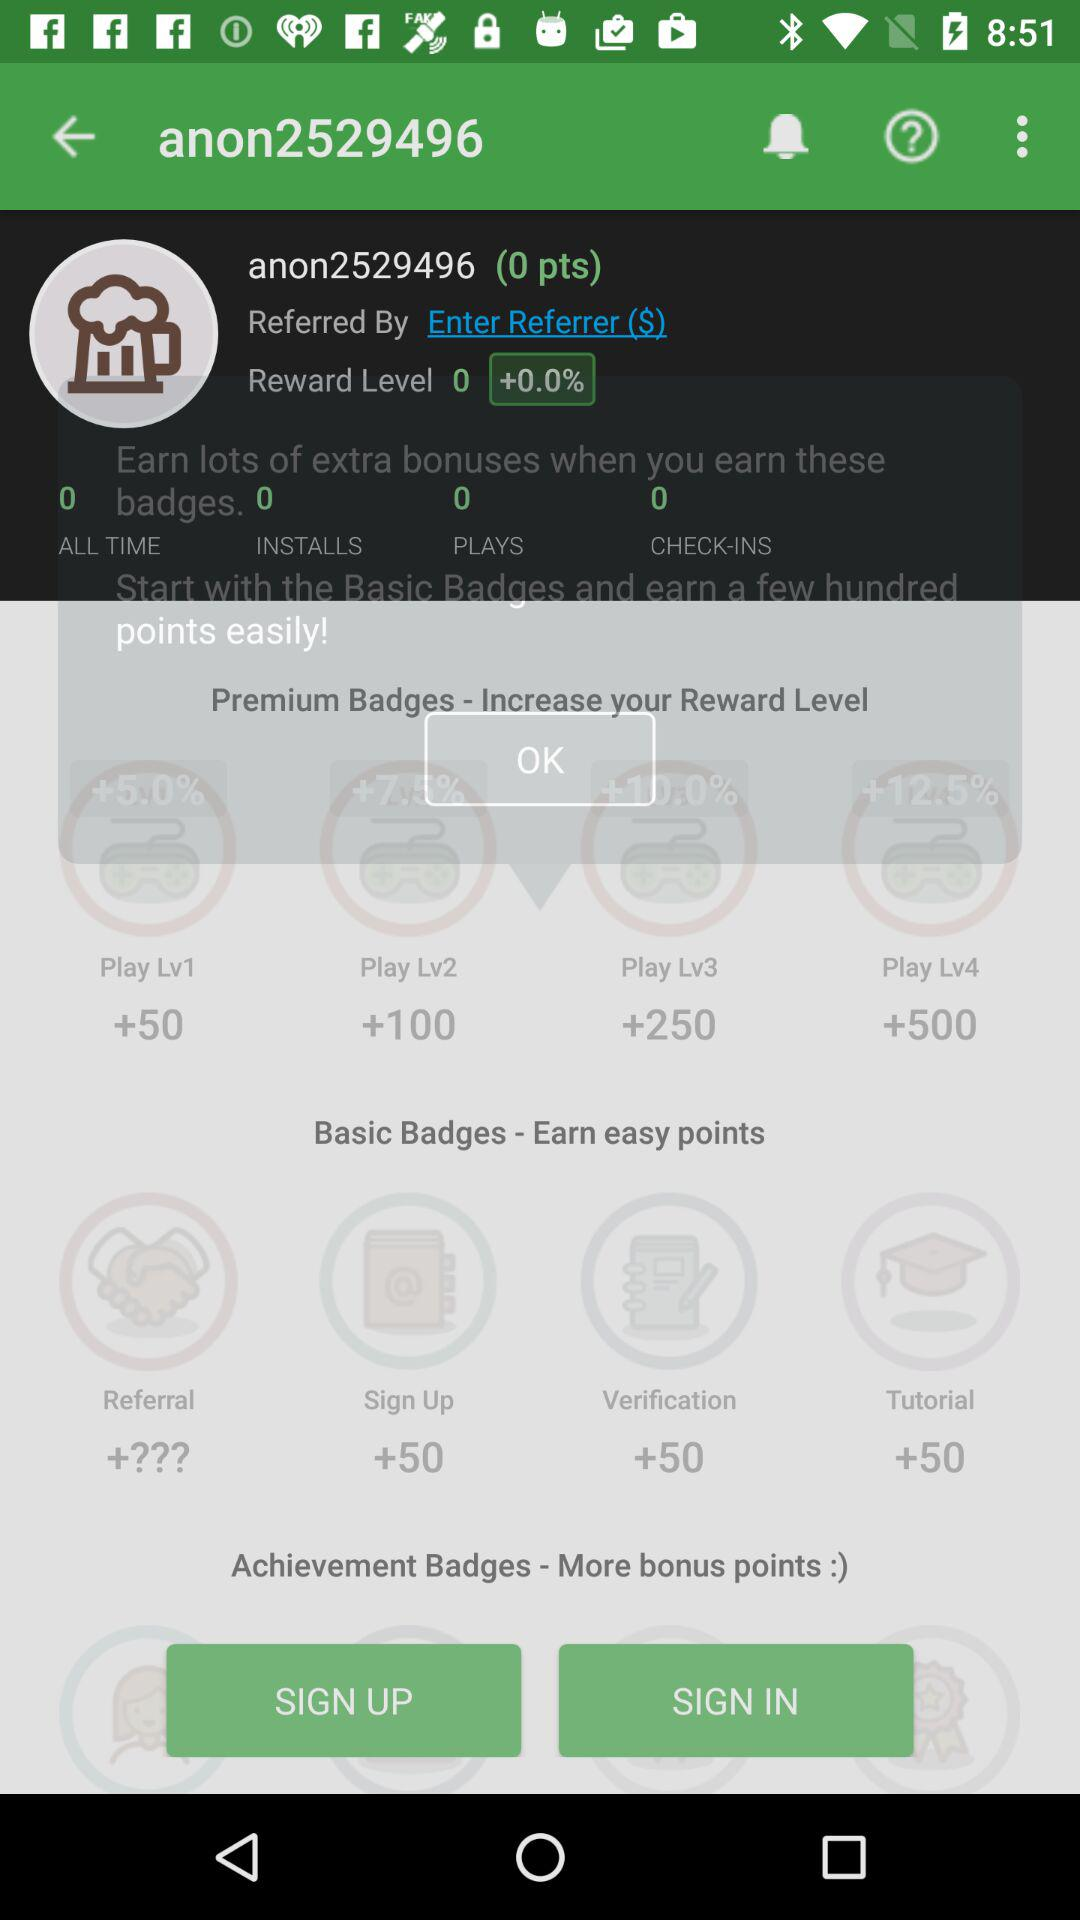What is the shown reward level? The shown reward level is 0. 